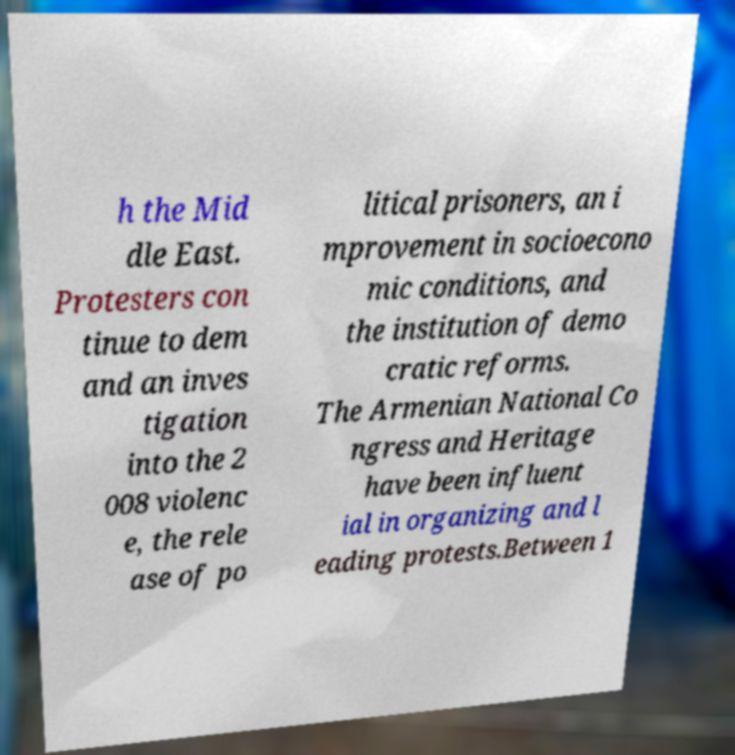Can you accurately transcribe the text from the provided image for me? h the Mid dle East. Protesters con tinue to dem and an inves tigation into the 2 008 violenc e, the rele ase of po litical prisoners, an i mprovement in socioecono mic conditions, and the institution of demo cratic reforms. The Armenian National Co ngress and Heritage have been influent ial in organizing and l eading protests.Between 1 